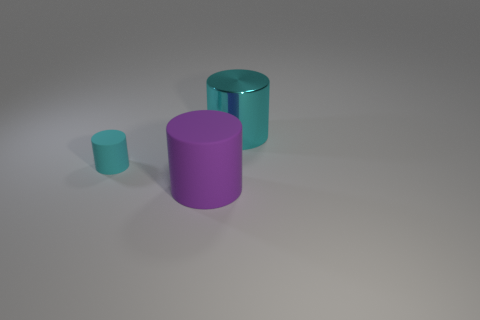Is there any other thing that has the same material as the large cyan object?
Offer a very short reply. No. What is the shape of the big purple rubber thing?
Give a very brief answer. Cylinder. What size is the metallic cylinder that is the same color as the tiny rubber cylinder?
Ensure brevity in your answer.  Large. There is a thing to the left of the rubber thing that is to the right of the small cylinder; what size is it?
Offer a terse response. Small. What size is the cyan cylinder in front of the cyan shiny thing?
Offer a very short reply. Small. Are there fewer large cyan metal objects left of the tiny cylinder than big metal cylinders behind the big cyan cylinder?
Make the answer very short. No. What color is the tiny matte cylinder?
Make the answer very short. Cyan. Are there any blocks that have the same color as the big metallic object?
Make the answer very short. No. The cyan object that is behind the cyan thing that is to the left of the cyan cylinder on the right side of the tiny cyan cylinder is what shape?
Offer a terse response. Cylinder. What is the thing that is in front of the cyan rubber cylinder made of?
Your answer should be very brief. Rubber. 